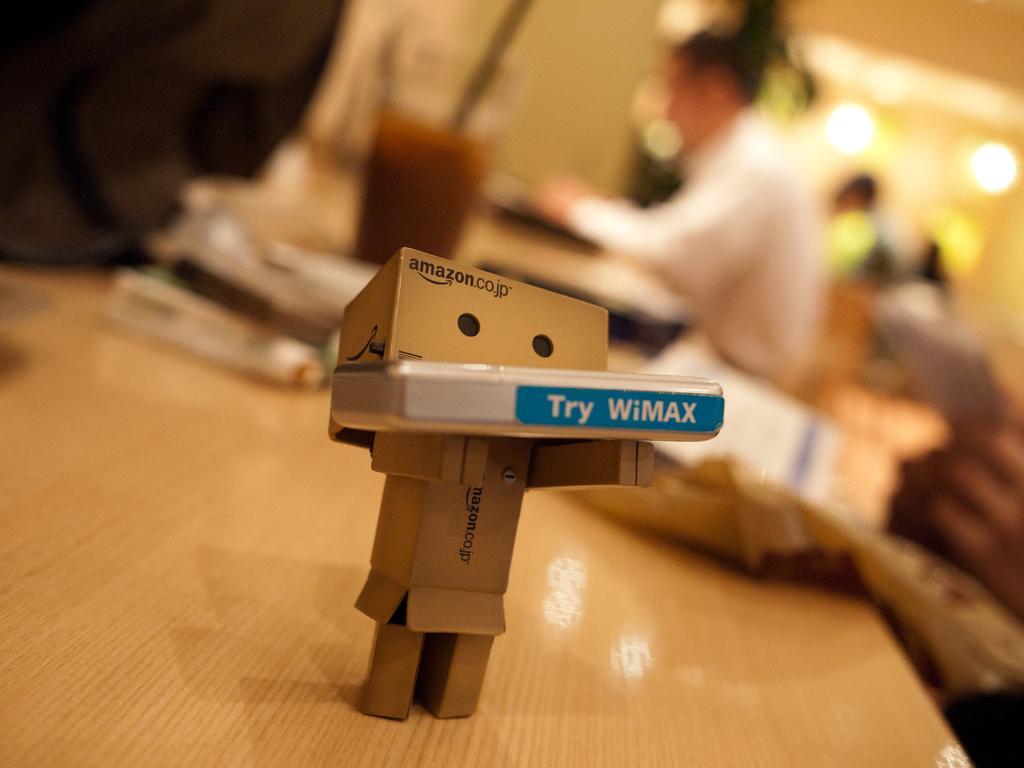Can you describe this image briefly? This picture is clicked inside. In the foreground there is a wooden table on the top of which boxes and some other items are placed. The background of the image is blurry and we can see a person sitting on the chair and seems to be working and we can see the lights, wall and group of persons. 